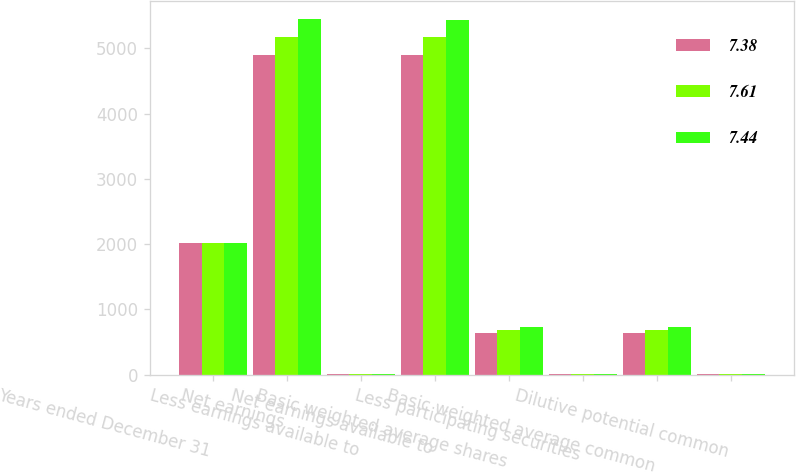Convert chart to OTSL. <chart><loc_0><loc_0><loc_500><loc_500><stacked_bar_chart><ecel><fcel>Years ended December 31<fcel>Net earnings<fcel>Less earnings available to<fcel>Net earnings available to<fcel>Basic weighted average shares<fcel>Less participating securities<fcel>Basic weighted average common<fcel>Dilutive potential common<nl><fcel>7.38<fcel>2016<fcel>4895<fcel>3<fcel>4892<fcel>636.5<fcel>1<fcel>635.5<fcel>7.3<nl><fcel>7.61<fcel>2015<fcel>5176<fcel>4<fcel>5172<fcel>688<fcel>1.1<fcel>686.9<fcel>8.1<nl><fcel>7.44<fcel>2014<fcel>5446<fcel>6<fcel>5440<fcel>728.9<fcel>1.3<fcel>727.6<fcel>9.1<nl></chart> 